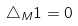Convert formula to latex. <formula><loc_0><loc_0><loc_500><loc_500>\triangle _ { M } 1 = 0</formula> 